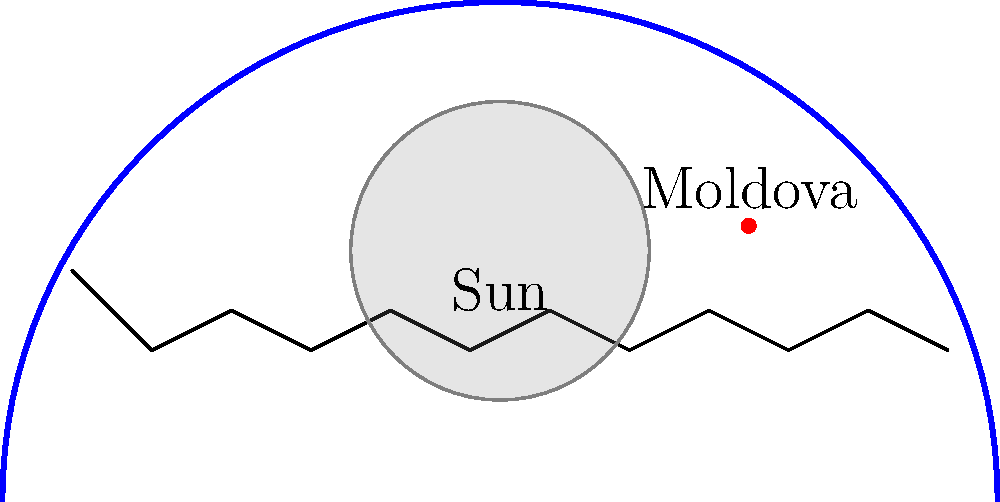Based on the illustration of a solar eclipse path across Europe, which direction is the eclipse likely to move, and how might this affect Moldova's view of the event? To answer this question, let's analyze the image step-by-step:

1. The blue curved line represents the path of the solar eclipse across Europe.
2. The path starts from the bottom left of the image and curves upwards towards the top right before descending again.
3. In astronomical events like solar eclipses, the shadow typically moves from west to east due to the Earth's rotation.
4. Given this information, we can deduce that the eclipse is moving from southwest to northeast.
5. Moldova is marked with a red dot on the right side of the illustration.
6. The eclipse path does not directly cross Moldova but passes to its northwest.

Considering Moldova's position relative to the eclipse path:
- Moldova will not experience a total solar eclipse.
- However, it will likely observe a partial solar eclipse.
- The extent of the partial eclipse visible from Moldova will depend on how close the country is to the path of totality.
- As the eclipse moves northeast, Moldova will see the moon partially covering the sun, with the coverage increasing and then decreasing as the eclipse progresses.

This event could be of particular interest to Moldovan citizens as it represents a shared European experience, potentially fostering a sense of connection with other European nations observing the same astronomical phenomenon.
Answer: Southwest to northeast; partial eclipse visible in Moldova 